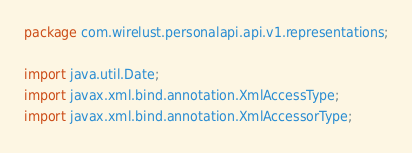Convert code to text. <code><loc_0><loc_0><loc_500><loc_500><_Java_>package com.wirelust.personalapi.api.v1.representations;

import java.util.Date;
import javax.xml.bind.annotation.XmlAccessType;
import javax.xml.bind.annotation.XmlAccessorType;</code> 